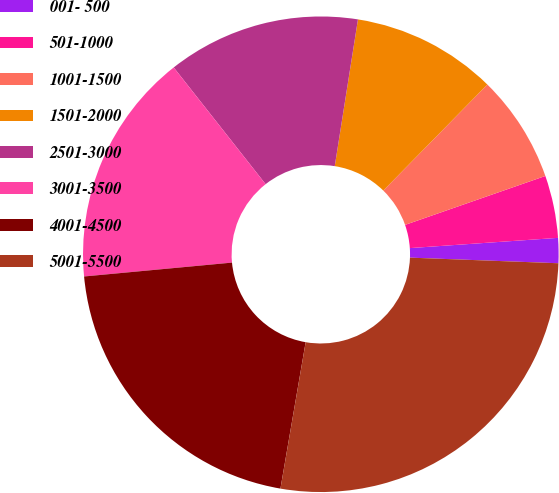Convert chart. <chart><loc_0><loc_0><loc_500><loc_500><pie_chart><fcel>001- 500<fcel>501-1000<fcel>1001-1500<fcel>1501-2000<fcel>2501-3000<fcel>3001-3500<fcel>4001-4500<fcel>5001-5500<nl><fcel>1.7%<fcel>4.24%<fcel>7.31%<fcel>9.85%<fcel>13.11%<fcel>15.87%<fcel>20.79%<fcel>27.11%<nl></chart> 